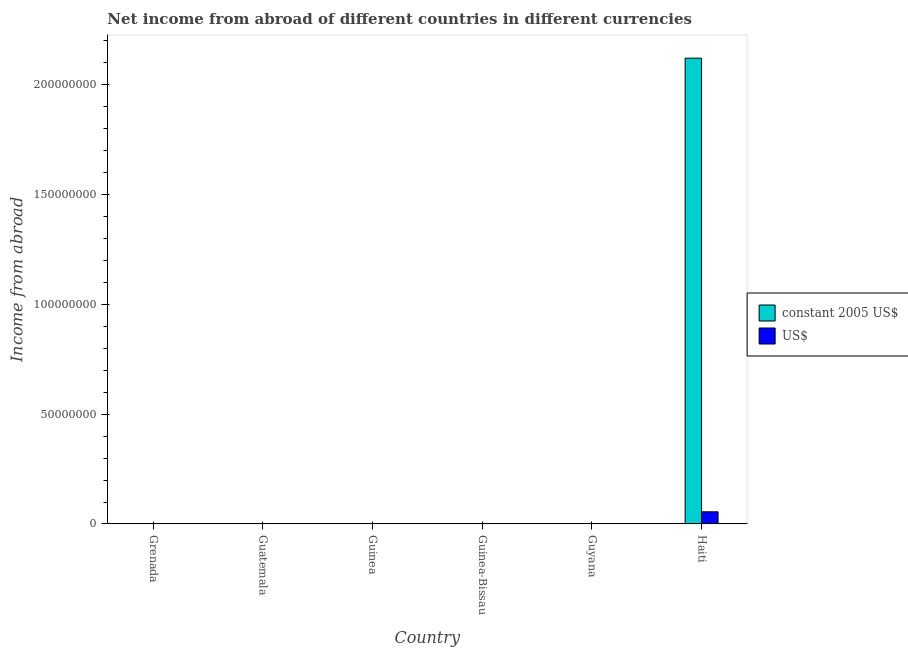Are the number of bars on each tick of the X-axis equal?
Provide a short and direct response. No. How many bars are there on the 4th tick from the right?
Make the answer very short. 0. What is the label of the 5th group of bars from the left?
Make the answer very short. Guyana. In how many cases, is the number of bars for a given country not equal to the number of legend labels?
Offer a terse response. 5. What is the income from abroad in constant 2005 us$ in Grenada?
Provide a short and direct response. 0. Across all countries, what is the maximum income from abroad in constant 2005 us$?
Ensure brevity in your answer.  2.12e+08. Across all countries, what is the minimum income from abroad in us$?
Your response must be concise. 0. In which country was the income from abroad in us$ maximum?
Keep it short and to the point. Haiti. What is the total income from abroad in us$ in the graph?
Give a very brief answer. 5.54e+06. What is the difference between the income from abroad in constant 2005 us$ in Guyana and the income from abroad in us$ in Guinea-Bissau?
Ensure brevity in your answer.  0. What is the average income from abroad in constant 2005 us$ per country?
Your answer should be very brief. 3.53e+07. What is the difference between the income from abroad in us$ and income from abroad in constant 2005 us$ in Haiti?
Provide a succinct answer. -2.06e+08. What is the difference between the highest and the lowest income from abroad in us$?
Provide a short and direct response. 5.54e+06. In how many countries, is the income from abroad in us$ greater than the average income from abroad in us$ taken over all countries?
Your response must be concise. 1. How many bars are there?
Your answer should be compact. 2. What is the difference between two consecutive major ticks on the Y-axis?
Offer a terse response. 5.00e+07. Does the graph contain any zero values?
Your response must be concise. Yes. Does the graph contain grids?
Provide a succinct answer. No. How are the legend labels stacked?
Your answer should be compact. Vertical. What is the title of the graph?
Ensure brevity in your answer.  Net income from abroad of different countries in different currencies. What is the label or title of the Y-axis?
Offer a terse response. Income from abroad. What is the Income from abroad of constant 2005 US$ in Guatemala?
Your answer should be compact. 0. What is the Income from abroad in US$ in Guatemala?
Offer a very short reply. 0. What is the Income from abroad of constant 2005 US$ in Guinea-Bissau?
Give a very brief answer. 0. What is the Income from abroad in US$ in Guyana?
Ensure brevity in your answer.  0. What is the Income from abroad of constant 2005 US$ in Haiti?
Your response must be concise. 2.12e+08. What is the Income from abroad of US$ in Haiti?
Your answer should be very brief. 5.54e+06. Across all countries, what is the maximum Income from abroad in constant 2005 US$?
Offer a very short reply. 2.12e+08. Across all countries, what is the maximum Income from abroad of US$?
Your answer should be compact. 5.54e+06. Across all countries, what is the minimum Income from abroad in constant 2005 US$?
Keep it short and to the point. 0. Across all countries, what is the minimum Income from abroad of US$?
Make the answer very short. 0. What is the total Income from abroad of constant 2005 US$ in the graph?
Your response must be concise. 2.12e+08. What is the total Income from abroad of US$ in the graph?
Provide a short and direct response. 5.54e+06. What is the average Income from abroad of constant 2005 US$ per country?
Ensure brevity in your answer.  3.53e+07. What is the average Income from abroad of US$ per country?
Give a very brief answer. 9.23e+05. What is the difference between the Income from abroad in constant 2005 US$ and Income from abroad in US$ in Haiti?
Ensure brevity in your answer.  2.06e+08. What is the difference between the highest and the lowest Income from abroad in constant 2005 US$?
Your answer should be very brief. 2.12e+08. What is the difference between the highest and the lowest Income from abroad of US$?
Your answer should be very brief. 5.54e+06. 